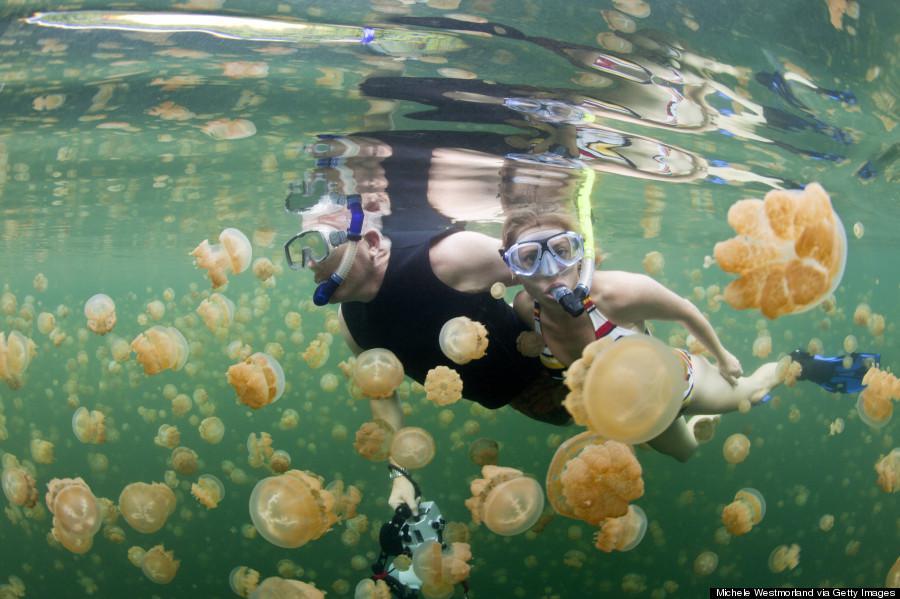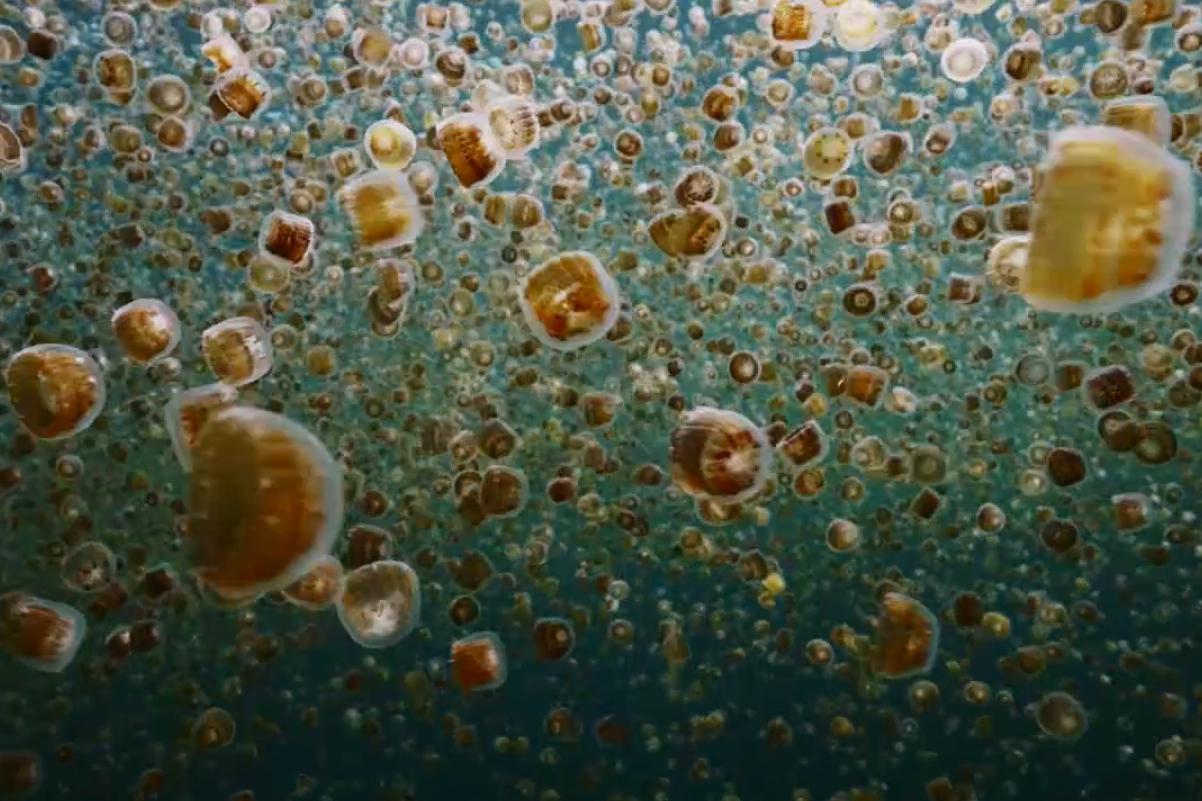The first image is the image on the left, the second image is the image on the right. Given the left and right images, does the statement "there is exactly one person in the image on the right." hold true? Answer yes or no. No. The first image is the image on the left, the second image is the image on the right. Evaluate the accuracy of this statement regarding the images: "There is a single large jellyfish in the image on the right.". Is it true? Answer yes or no. No. 